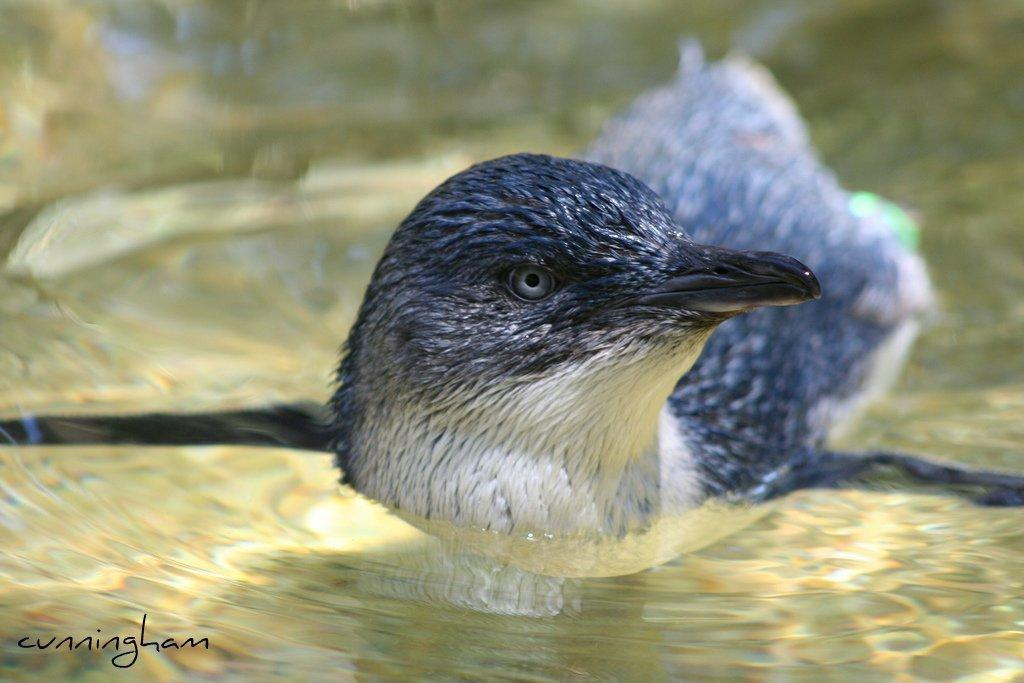What is the main subject of the image? The main subject of the image is a bird. Where is the bird located in the image? The bird is in the center of the image. What is the bird's position in relation to the water? The bird is on the water. What type of statement can be heard coming from the bird in the image? There is no indication in the image that the bird is making any statements, as birds do not have the ability to speak or make statements. 